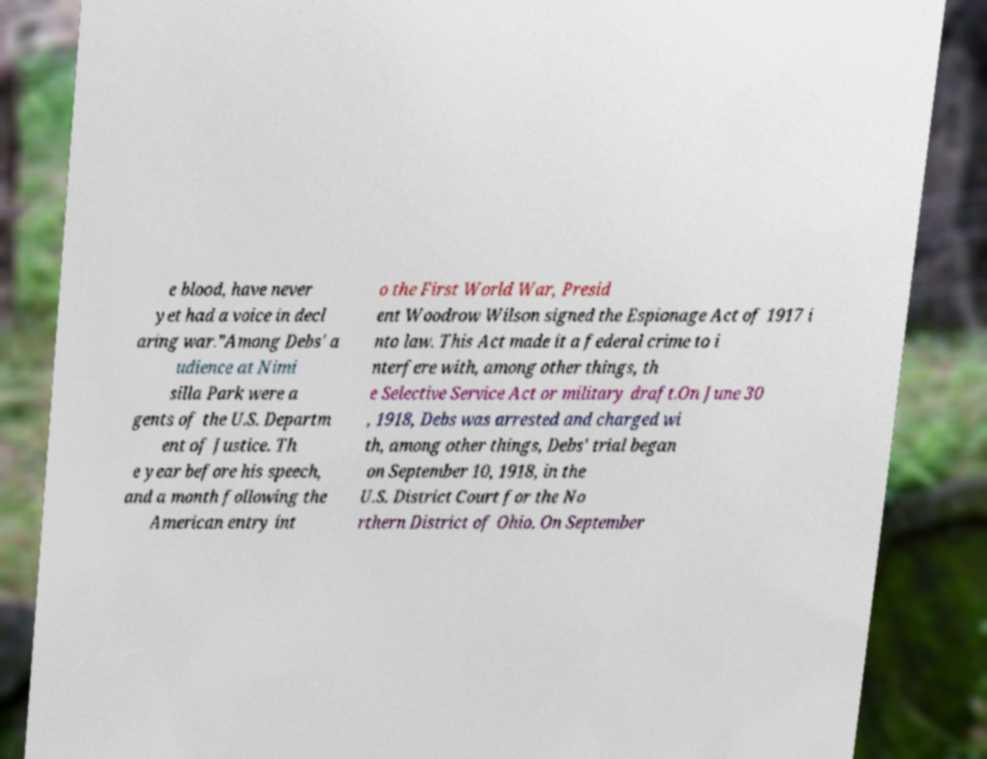Can you read and provide the text displayed in the image?This photo seems to have some interesting text. Can you extract and type it out for me? e blood, have never yet had a voice in decl aring war.”Among Debs' a udience at Nimi silla Park were a gents of the U.S. Departm ent of Justice. Th e year before his speech, and a month following the American entry int o the First World War, Presid ent Woodrow Wilson signed the Espionage Act of 1917 i nto law. This Act made it a federal crime to i nterfere with, among other things, th e Selective Service Act or military draft.On June 30 , 1918, Debs was arrested and charged wi th, among other things, Debs' trial began on September 10, 1918, in the U.S. District Court for the No rthern District of Ohio. On September 